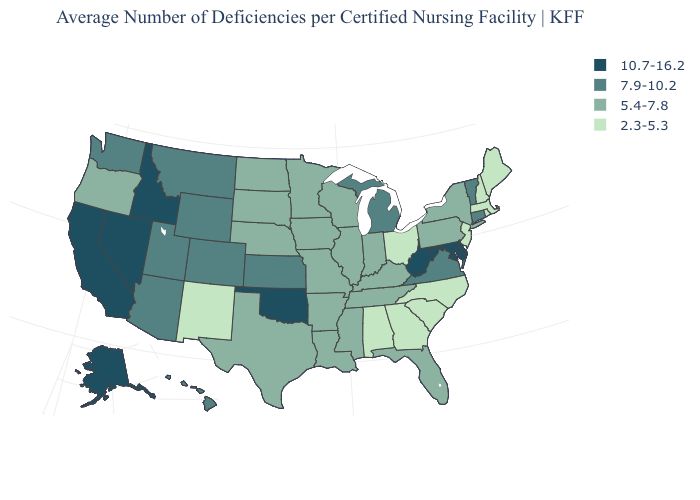What is the value of Maine?
Give a very brief answer. 2.3-5.3. Is the legend a continuous bar?
Short answer required. No. Among the states that border Tennessee , does North Carolina have the lowest value?
Give a very brief answer. Yes. What is the highest value in states that border North Carolina?
Short answer required. 7.9-10.2. Among the states that border South Carolina , which have the highest value?
Quick response, please. Georgia, North Carolina. Which states have the lowest value in the USA?
Give a very brief answer. Alabama, Georgia, Maine, Massachusetts, New Hampshire, New Jersey, New Mexico, North Carolina, Ohio, Rhode Island, South Carolina. Does Mississippi have a higher value than North Carolina?
Keep it brief. Yes. Name the states that have a value in the range 5.4-7.8?
Quick response, please. Arkansas, Florida, Illinois, Indiana, Iowa, Kentucky, Louisiana, Minnesota, Mississippi, Missouri, Nebraska, New York, North Dakota, Oregon, Pennsylvania, South Dakota, Tennessee, Texas, Wisconsin. Does the map have missing data?
Quick response, please. No. What is the highest value in states that border Delaware?
Short answer required. 10.7-16.2. Among the states that border Alabama , which have the lowest value?
Give a very brief answer. Georgia. Name the states that have a value in the range 5.4-7.8?
Keep it brief. Arkansas, Florida, Illinois, Indiana, Iowa, Kentucky, Louisiana, Minnesota, Mississippi, Missouri, Nebraska, New York, North Dakota, Oregon, Pennsylvania, South Dakota, Tennessee, Texas, Wisconsin. What is the value of Illinois?
Give a very brief answer. 5.4-7.8. Name the states that have a value in the range 5.4-7.8?
Answer briefly. Arkansas, Florida, Illinois, Indiana, Iowa, Kentucky, Louisiana, Minnesota, Mississippi, Missouri, Nebraska, New York, North Dakota, Oregon, Pennsylvania, South Dakota, Tennessee, Texas, Wisconsin. How many symbols are there in the legend?
Quick response, please. 4. 